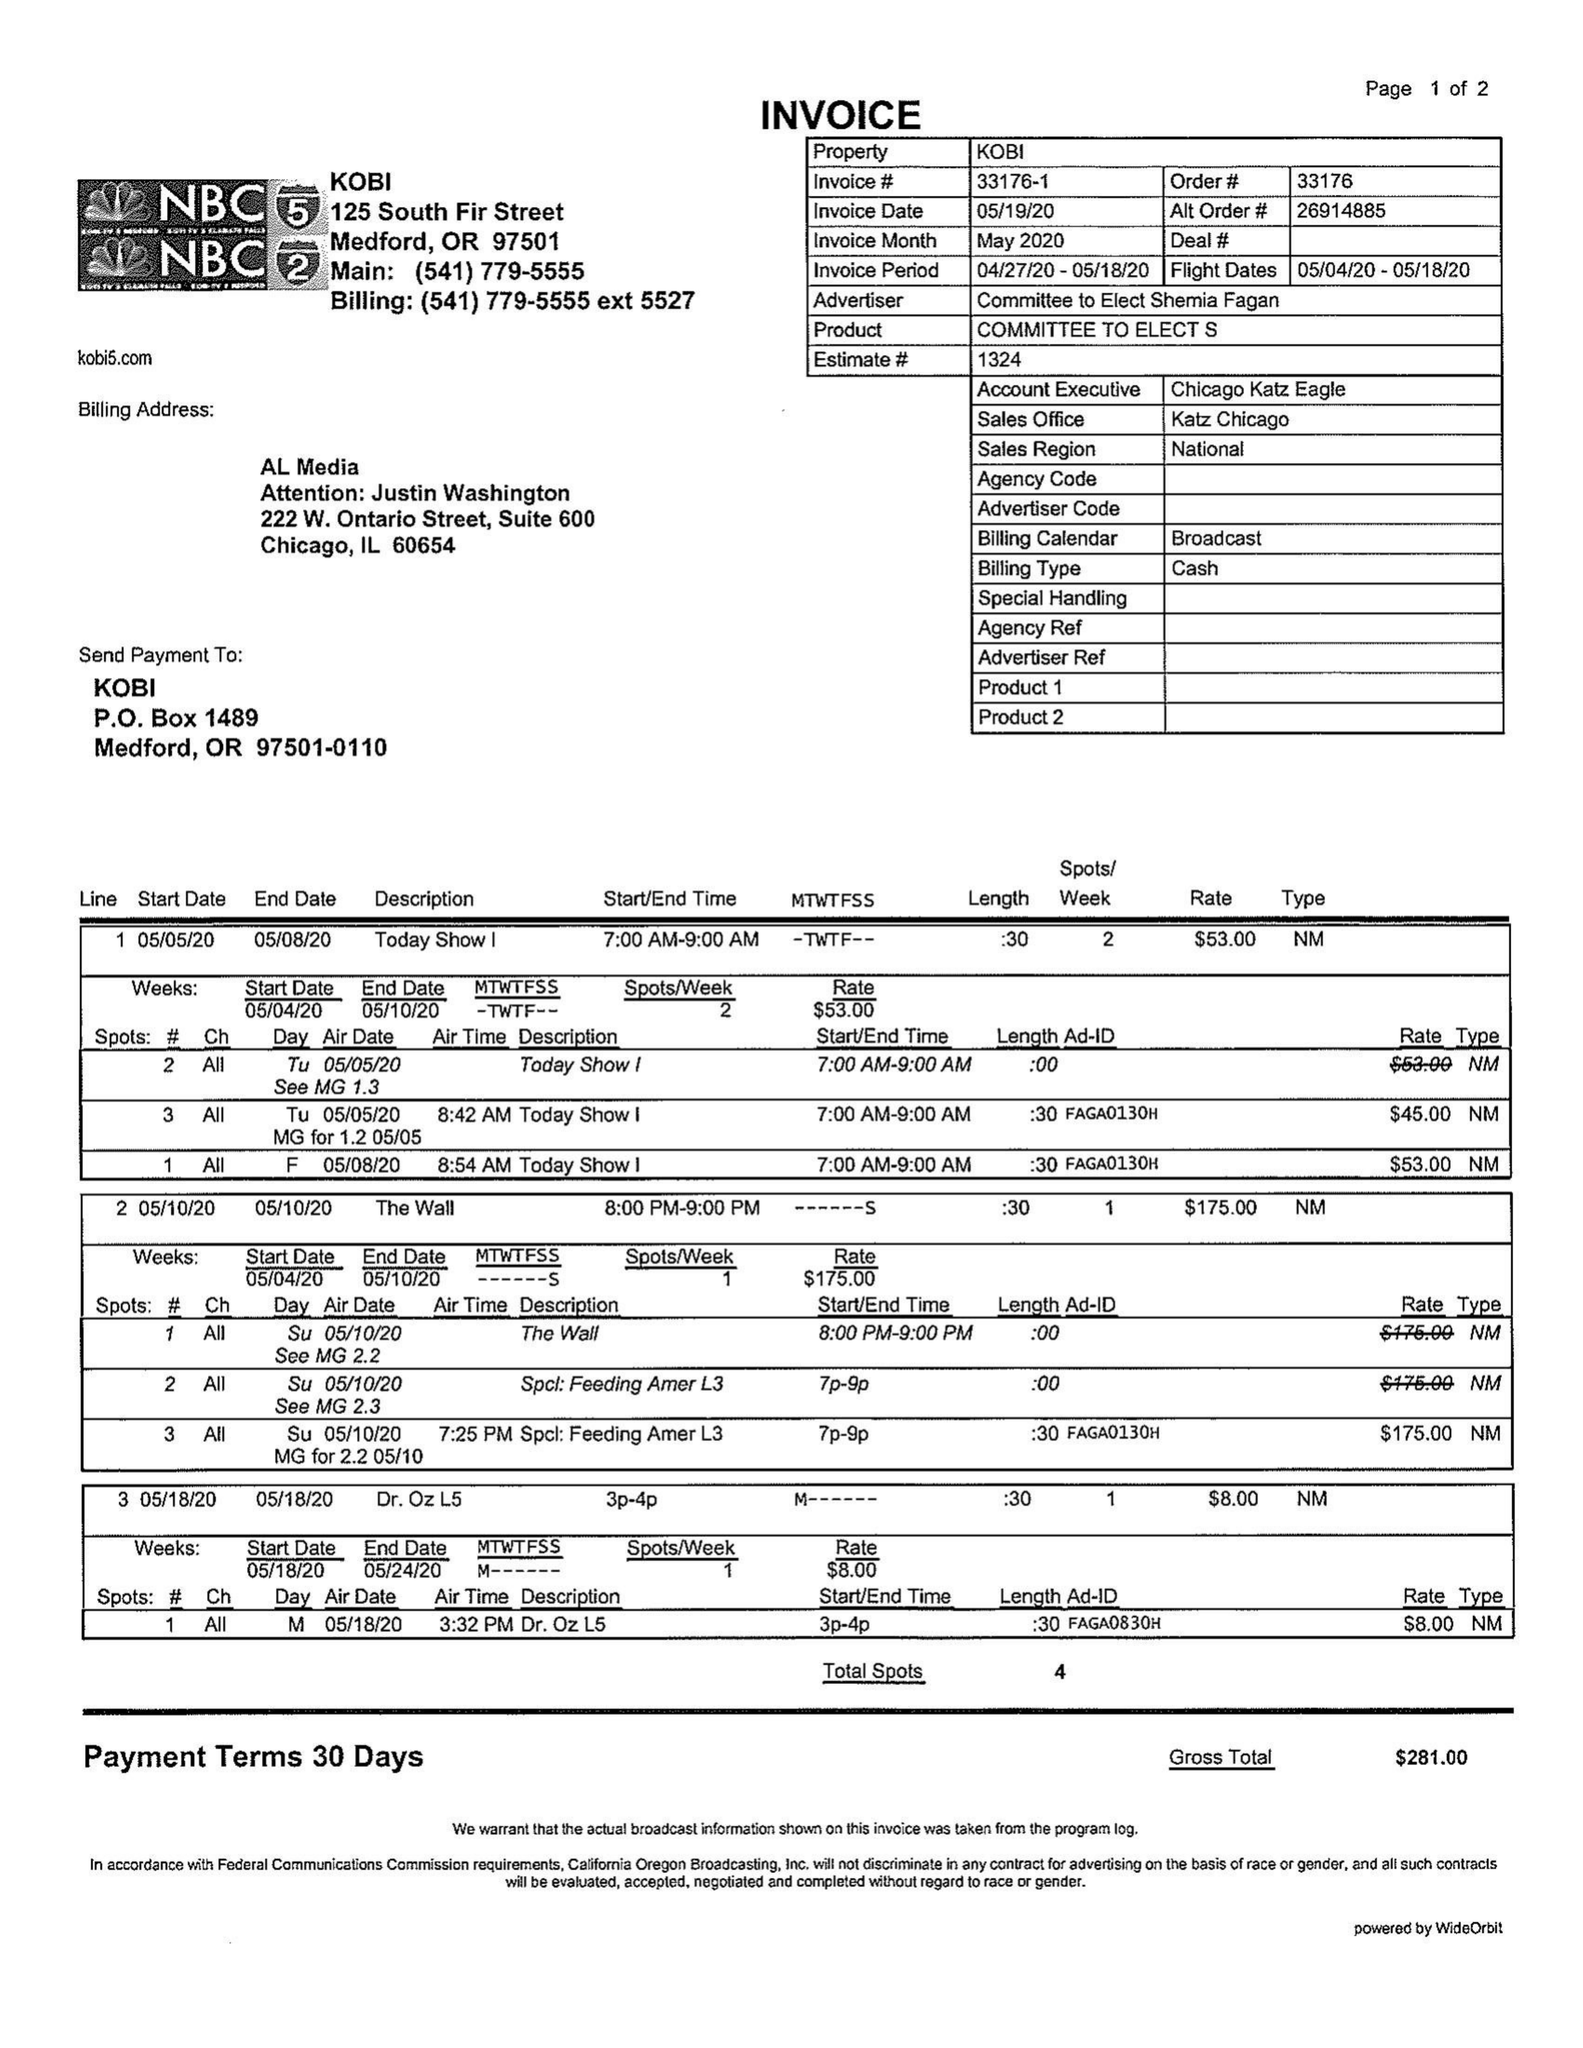What is the value for the advertiser?
Answer the question using a single word or phrase. COMMITTEE TO ELECT SHEMIA FAGAN 